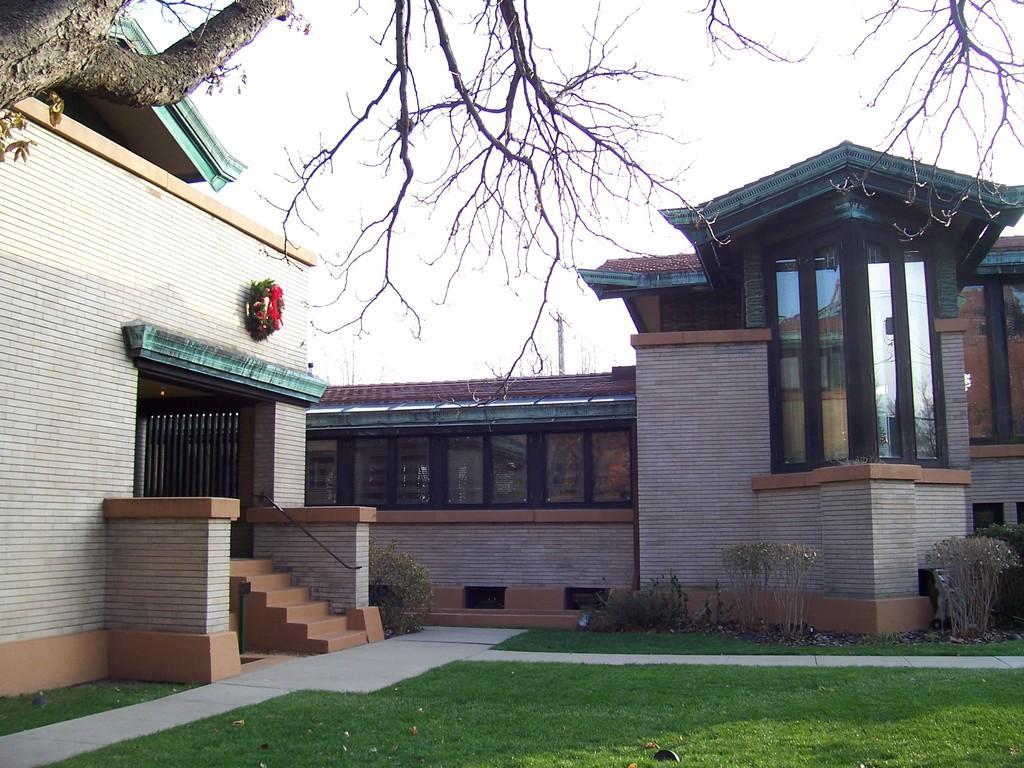Could you give a brief overview of what you see in this image? In this image we can see the lawn, plants, house, garland, a tree and the sky in the background. 